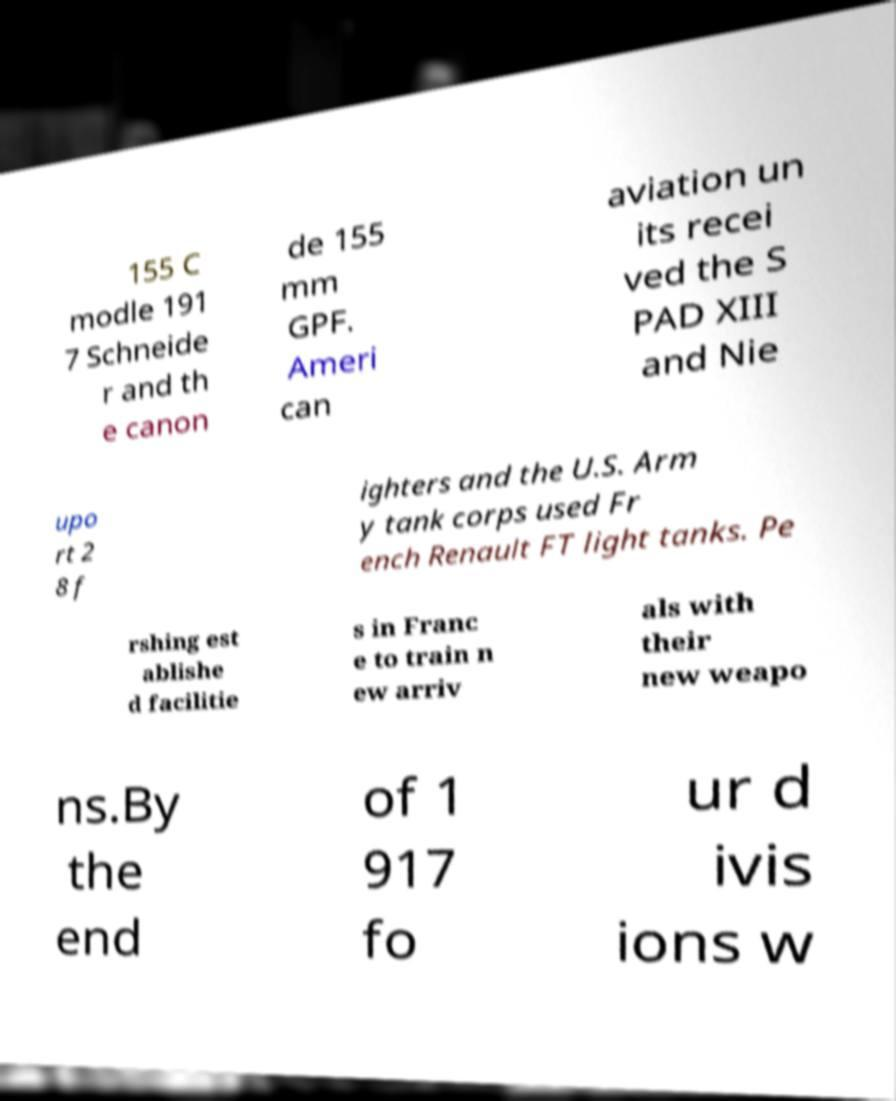Please identify and transcribe the text found in this image. 155 C modle 191 7 Schneide r and th e canon de 155 mm GPF. Ameri can aviation un its recei ved the S PAD XIII and Nie upo rt 2 8 f ighters and the U.S. Arm y tank corps used Fr ench Renault FT light tanks. Pe rshing est ablishe d facilitie s in Franc e to train n ew arriv als with their new weapo ns.By the end of 1 917 fo ur d ivis ions w 